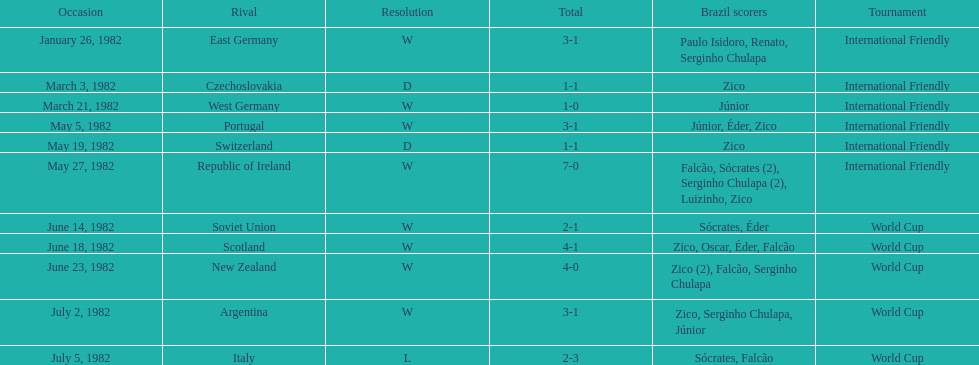What are the dates? January 26, 1982, March 3, 1982, March 21, 1982, May 5, 1982, May 19, 1982, May 27, 1982, June 14, 1982, June 18, 1982, June 23, 1982, July 2, 1982, July 5, 1982. And which date is listed first? January 26, 1982. 